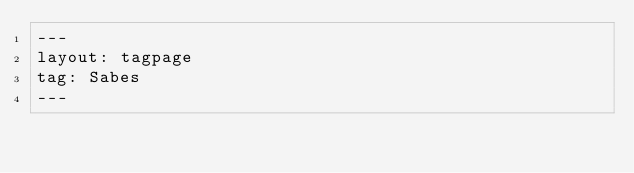Convert code to text. <code><loc_0><loc_0><loc_500><loc_500><_HTML_>---
layout: tagpage
tag: Sabes
---
</code> 